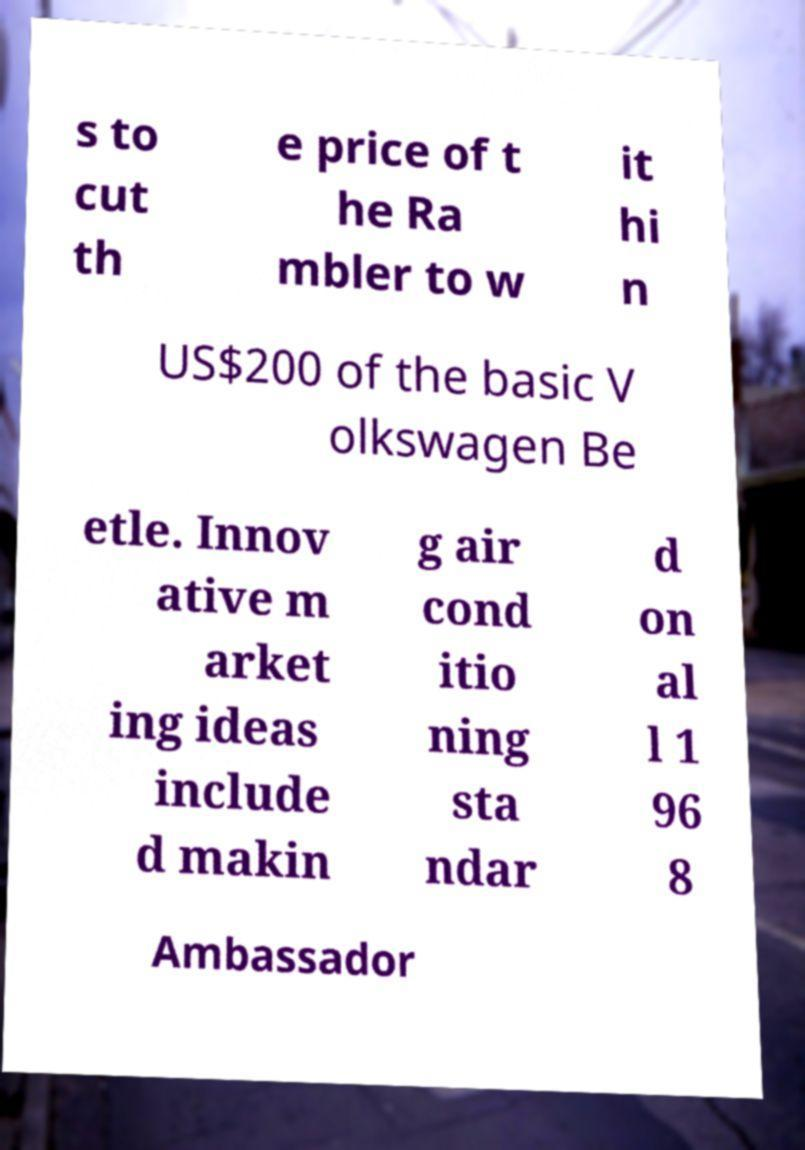Please identify and transcribe the text found in this image. s to cut th e price of t he Ra mbler to w it hi n US$200 of the basic V olkswagen Be etle. Innov ative m arket ing ideas include d makin g air cond itio ning sta ndar d on al l 1 96 8 Ambassador 